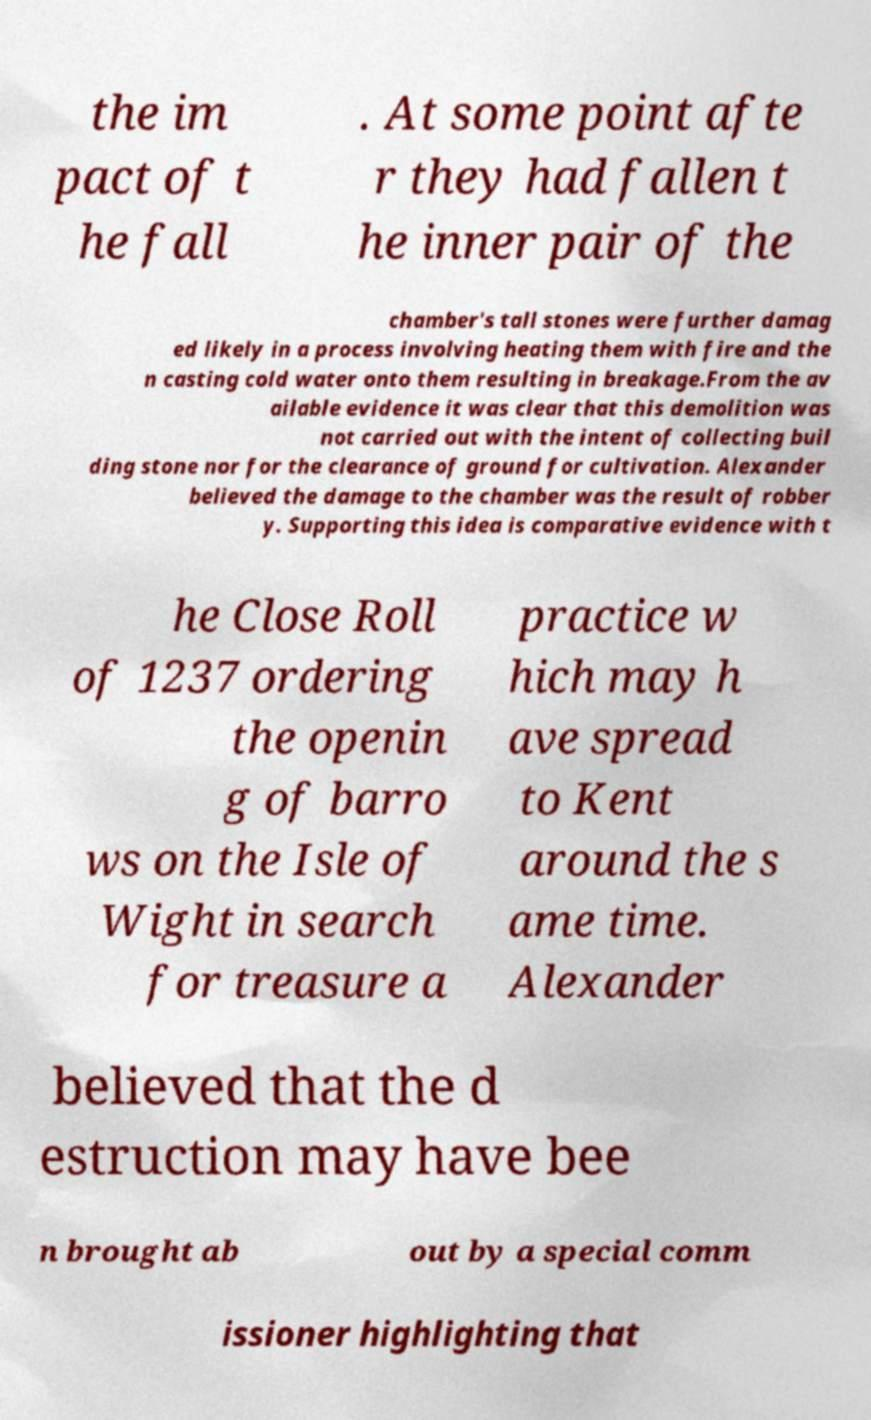Please identify and transcribe the text found in this image. the im pact of t he fall . At some point afte r they had fallen t he inner pair of the chamber's tall stones were further damag ed likely in a process involving heating them with fire and the n casting cold water onto them resulting in breakage.From the av ailable evidence it was clear that this demolition was not carried out with the intent of collecting buil ding stone nor for the clearance of ground for cultivation. Alexander believed the damage to the chamber was the result of robber y. Supporting this idea is comparative evidence with t he Close Roll of 1237 ordering the openin g of barro ws on the Isle of Wight in search for treasure a practice w hich may h ave spread to Kent around the s ame time. Alexander believed that the d estruction may have bee n brought ab out by a special comm issioner highlighting that 